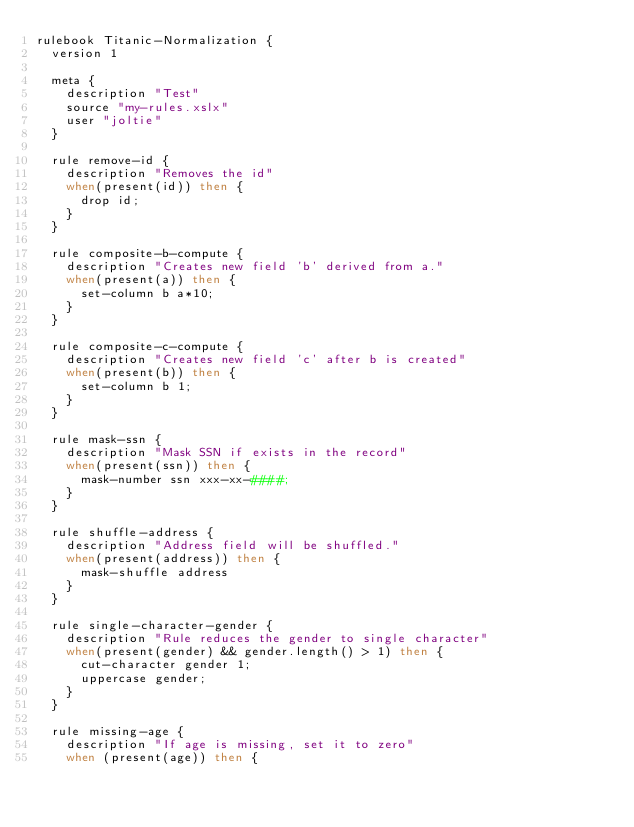Convert code to text. <code><loc_0><loc_0><loc_500><loc_500><_Ruby_>rulebook Titanic-Normalization {
  version 1

  meta {
    description "Test"
    source "my-rules.xslx"
    user "joltie"
  }

  rule remove-id {
    description "Removes the id"
    when(present(id)) then {
      drop id;
    }
  }

  rule composite-b-compute {
    description "Creates new field 'b' derived from a."
    when(present(a)) then {
      set-column b a*10;
    }
  }

  rule composite-c-compute {
    description "Creates new field 'c' after b is created"
    when(present(b)) then {
      set-column b 1;
    }
  }

  rule mask-ssn {
    description "Mask SSN if exists in the record"
    when(present(ssn)) then {
      mask-number ssn xxx-xx-####;
    }
  }

  rule shuffle-address {
    description "Address field will be shuffled."
    when(present(address)) then {
      mask-shuffle address
    }
  }

  rule single-character-gender {
    description "Rule reduces the gender to single character"
    when(present(gender) && gender.length() > 1) then {
      cut-character gender 1;
      uppercase gender;
    }
  }

  rule missing-age {
    description "If age is missing, set it to zero"
    when (present(age)) then {</code> 